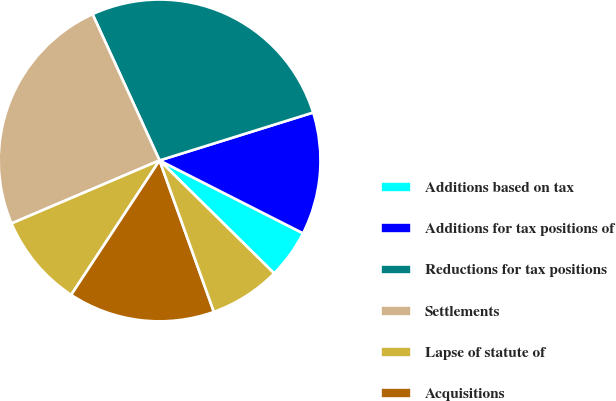<chart> <loc_0><loc_0><loc_500><loc_500><pie_chart><fcel>Additions based on tax<fcel>Additions for tax positions of<fcel>Reductions for tax positions<fcel>Settlements<fcel>Lapse of statute of<fcel>Acquisitions<fcel>Foreign currency translation<nl><fcel>4.91%<fcel>12.29%<fcel>27.03%<fcel>24.57%<fcel>9.34%<fcel>14.74%<fcel>7.13%<nl></chart> 